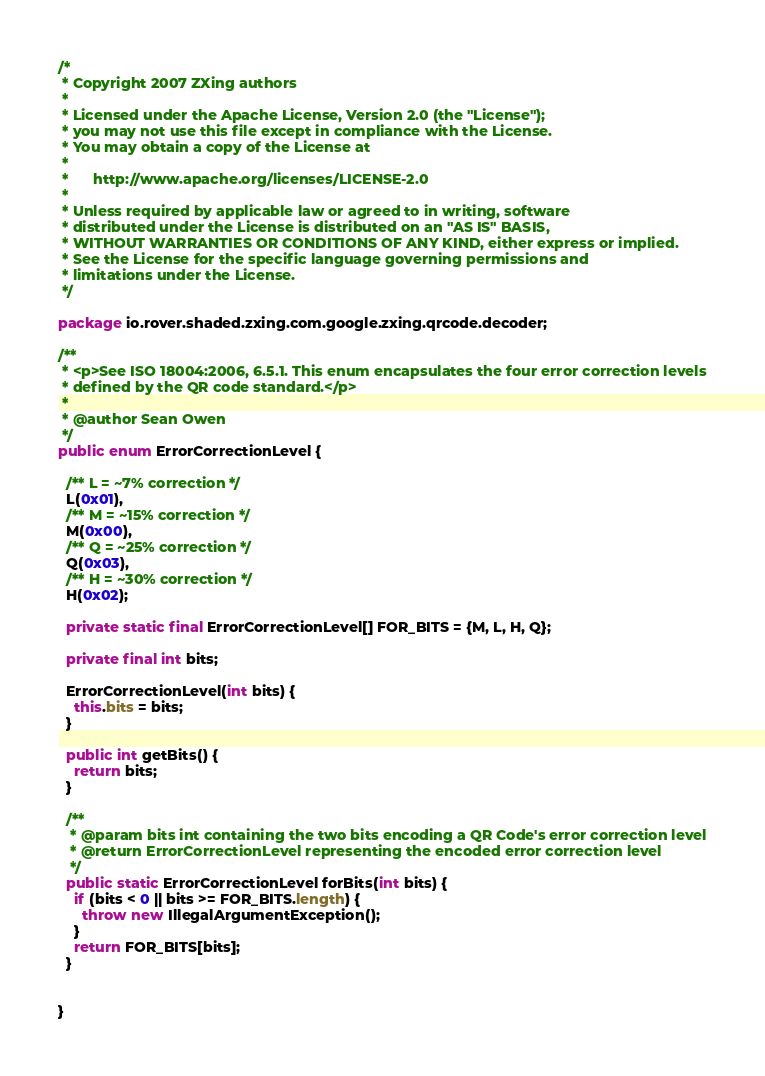<code> <loc_0><loc_0><loc_500><loc_500><_Java_>/*
 * Copyright 2007 ZXing authors
 *
 * Licensed under the Apache License, Version 2.0 (the "License");
 * you may not use this file except in compliance with the License.
 * You may obtain a copy of the License at
 *
 *      http://www.apache.org/licenses/LICENSE-2.0
 *
 * Unless required by applicable law or agreed to in writing, software
 * distributed under the License is distributed on an "AS IS" BASIS,
 * WITHOUT WARRANTIES OR CONDITIONS OF ANY KIND, either express or implied.
 * See the License for the specific language governing permissions and
 * limitations under the License.
 */

package io.rover.shaded.zxing.com.google.zxing.qrcode.decoder;

/**
 * <p>See ISO 18004:2006, 6.5.1. This enum encapsulates the four error correction levels
 * defined by the QR code standard.</p>
 *
 * @author Sean Owen
 */
public enum ErrorCorrectionLevel {

  /** L = ~7% correction */
  L(0x01),
  /** M = ~15% correction */
  M(0x00),
  /** Q = ~25% correction */
  Q(0x03),
  /** H = ~30% correction */
  H(0x02);

  private static final ErrorCorrectionLevel[] FOR_BITS = {M, L, H, Q};

  private final int bits;

  ErrorCorrectionLevel(int bits) {
    this.bits = bits;
  }

  public int getBits() {
    return bits;
  }

  /**
   * @param bits int containing the two bits encoding a QR Code's error correction level
   * @return ErrorCorrectionLevel representing the encoded error correction level
   */
  public static ErrorCorrectionLevel forBits(int bits) {
    if (bits < 0 || bits >= FOR_BITS.length) {
      throw new IllegalArgumentException();
    }
    return FOR_BITS[bits];
  }


}
</code> 